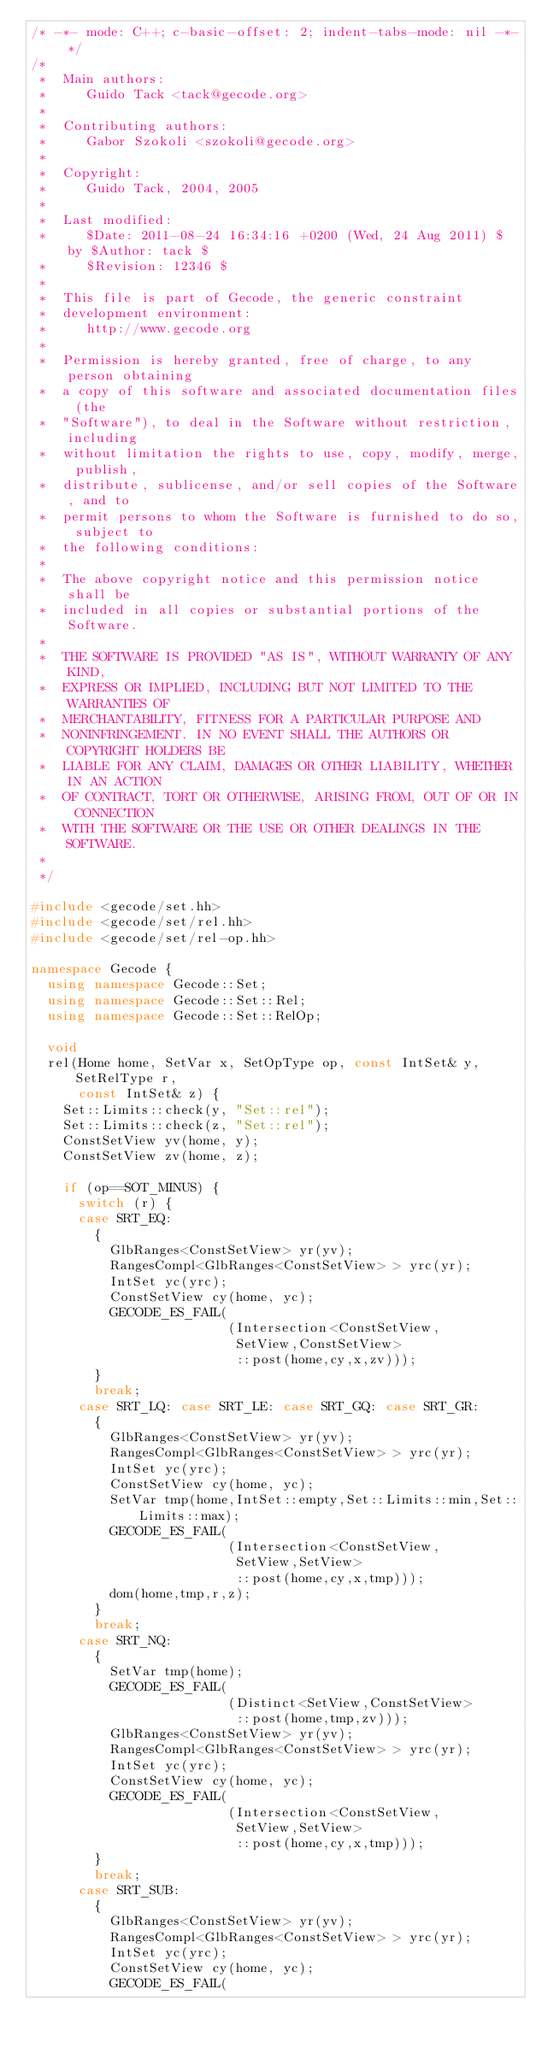<code> <loc_0><loc_0><loc_500><loc_500><_C++_>/* -*- mode: C++; c-basic-offset: 2; indent-tabs-mode: nil -*- */
/*
 *  Main authors:
 *     Guido Tack <tack@gecode.org>
 *
 *  Contributing authors:
 *     Gabor Szokoli <szokoli@gecode.org>
 *
 *  Copyright:
 *     Guido Tack, 2004, 2005
 *
 *  Last modified:
 *     $Date: 2011-08-24 16:34:16 +0200 (Wed, 24 Aug 2011) $ by $Author: tack $
 *     $Revision: 12346 $
 *
 *  This file is part of Gecode, the generic constraint
 *  development environment:
 *     http://www.gecode.org
 *
 *  Permission is hereby granted, free of charge, to any person obtaining
 *  a copy of this software and associated documentation files (the
 *  "Software"), to deal in the Software without restriction, including
 *  without limitation the rights to use, copy, modify, merge, publish,
 *  distribute, sublicense, and/or sell copies of the Software, and to
 *  permit persons to whom the Software is furnished to do so, subject to
 *  the following conditions:
 *
 *  The above copyright notice and this permission notice shall be
 *  included in all copies or substantial portions of the Software.
 *
 *  THE SOFTWARE IS PROVIDED "AS IS", WITHOUT WARRANTY OF ANY KIND,
 *  EXPRESS OR IMPLIED, INCLUDING BUT NOT LIMITED TO THE WARRANTIES OF
 *  MERCHANTABILITY, FITNESS FOR A PARTICULAR PURPOSE AND
 *  NONINFRINGEMENT. IN NO EVENT SHALL THE AUTHORS OR COPYRIGHT HOLDERS BE
 *  LIABLE FOR ANY CLAIM, DAMAGES OR OTHER LIABILITY, WHETHER IN AN ACTION
 *  OF CONTRACT, TORT OR OTHERWISE, ARISING FROM, OUT OF OR IN CONNECTION
 *  WITH THE SOFTWARE OR THE USE OR OTHER DEALINGS IN THE SOFTWARE.
 *
 */

#include <gecode/set.hh>
#include <gecode/set/rel.hh>
#include <gecode/set/rel-op.hh>

namespace Gecode {
  using namespace Gecode::Set;
  using namespace Gecode::Set::Rel;
  using namespace Gecode::Set::RelOp;

  void
  rel(Home home, SetVar x, SetOpType op, const IntSet& y, SetRelType r,
      const IntSet& z) {
    Set::Limits::check(y, "Set::rel");
    Set::Limits::check(z, "Set::rel");
    ConstSetView yv(home, y);
    ConstSetView zv(home, z);

    if (op==SOT_MINUS) {
      switch (r) {
      case SRT_EQ:
        {
          GlbRanges<ConstSetView> yr(yv);
          RangesCompl<GlbRanges<ConstSetView> > yrc(yr);
          IntSet yc(yrc);
          ConstSetView cy(home, yc);
          GECODE_ES_FAIL(
                         (Intersection<ConstSetView,
                          SetView,ConstSetView>
                          ::post(home,cy,x,zv)));
        }
        break;
      case SRT_LQ: case SRT_LE: case SRT_GQ: case SRT_GR:
        {
          GlbRanges<ConstSetView> yr(yv);
          RangesCompl<GlbRanges<ConstSetView> > yrc(yr);
          IntSet yc(yrc);
          ConstSetView cy(home, yc);
          SetVar tmp(home,IntSet::empty,Set::Limits::min,Set::Limits::max);
          GECODE_ES_FAIL(
                         (Intersection<ConstSetView,
                          SetView,SetView>
                          ::post(home,cy,x,tmp)));
          dom(home,tmp,r,z);
        }
        break;
      case SRT_NQ:
        {
          SetVar tmp(home);
          GECODE_ES_FAIL(
                         (Distinct<SetView,ConstSetView>
                          ::post(home,tmp,zv)));
          GlbRanges<ConstSetView> yr(yv);
          RangesCompl<GlbRanges<ConstSetView> > yrc(yr);
          IntSet yc(yrc);
          ConstSetView cy(home, yc);
          GECODE_ES_FAIL(
                         (Intersection<ConstSetView,
                          SetView,SetView>
                          ::post(home,cy,x,tmp)));
        }
        break;
      case SRT_SUB:
        {
          GlbRanges<ConstSetView> yr(yv);
          RangesCompl<GlbRanges<ConstSetView> > yrc(yr);
          IntSet yc(yrc);
          ConstSetView cy(home, yc);
          GECODE_ES_FAIL(</code> 